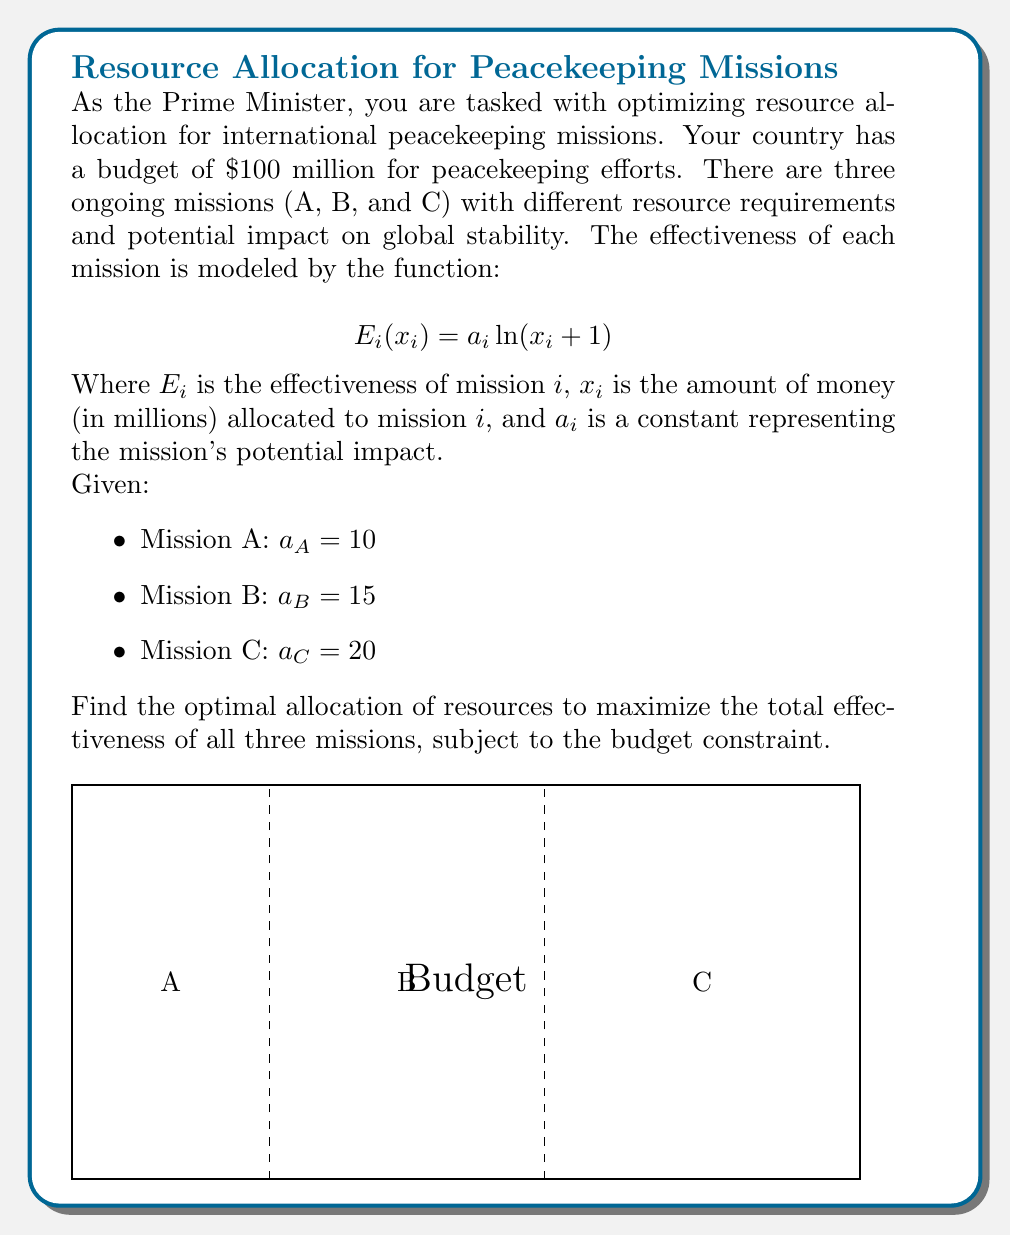Teach me how to tackle this problem. To solve this optimization problem, we'll use the method of Lagrange multipliers:

1) Define the objective function (total effectiveness):
   $$E_{total} = E_A + E_B + E_C = 10\ln(x_A + 1) + 15\ln(x_B + 1) + 20\ln(x_C + 1)$$

2) Define the constraint:
   $$x_A + x_B + x_C = 100$$

3) Form the Lagrangian:
   $$L = 10\ln(x_A + 1) + 15\ln(x_B + 1) + 20\ln(x_C + 1) - \lambda(x_A + x_B + x_C - 100)$$

4) Take partial derivatives and set them to zero:
   $$\frac{\partial L}{\partial x_A} = \frac{10}{x_A + 1} - \lambda = 0$$
   $$\frac{\partial L}{\partial x_B} = \frac{15}{x_B + 1} - \lambda = 0$$
   $$\frac{\partial L}{\partial x_C} = \frac{20}{x_C + 1} - \lambda = 0$$
   $$\frac{\partial L}{\partial \lambda} = x_A + x_B + x_C - 100 = 0$$

5) From these equations, we can deduce:
   $$\frac{10}{x_A + 1} = \frac{15}{x_B + 1} = \frac{20}{x_C + 1} = \lambda$$

6) This implies:
   $$x_A + 1 = \frac{10}{\lambda}, x_B + 1 = \frac{15}{\lambda}, x_C + 1 = \frac{20}{\lambda}$$

7) Substituting into the constraint equation:
   $$(\frac{10}{\lambda} - 1) + (\frac{15}{\lambda} - 1) + (\frac{20}{\lambda} - 1) = 100$$
   $$\frac{45}{\lambda} - 3 = 100$$
   $$\frac{45}{\lambda} = 103$$
   $$\lambda = \frac{45}{103}$$

8) Finally, we can calculate the optimal allocations:
   $$x_A = \frac{10}{\lambda} - 1 = \frac{10 \cdot 103}{45} - 1 \approx 21.89$$
   $$x_B = \frac{15}{\lambda} - 1 = \frac{15 \cdot 103}{45} - 1 \approx 33.33$$
   $$x_C = \frac{20}{\lambda} - 1 = \frac{20 \cdot 103}{45} - 1 \approx 44.78$$
Answer: $x_A \approx 21.89, x_B \approx 33.33, x_C \approx 44.78$ (in millions of dollars) 